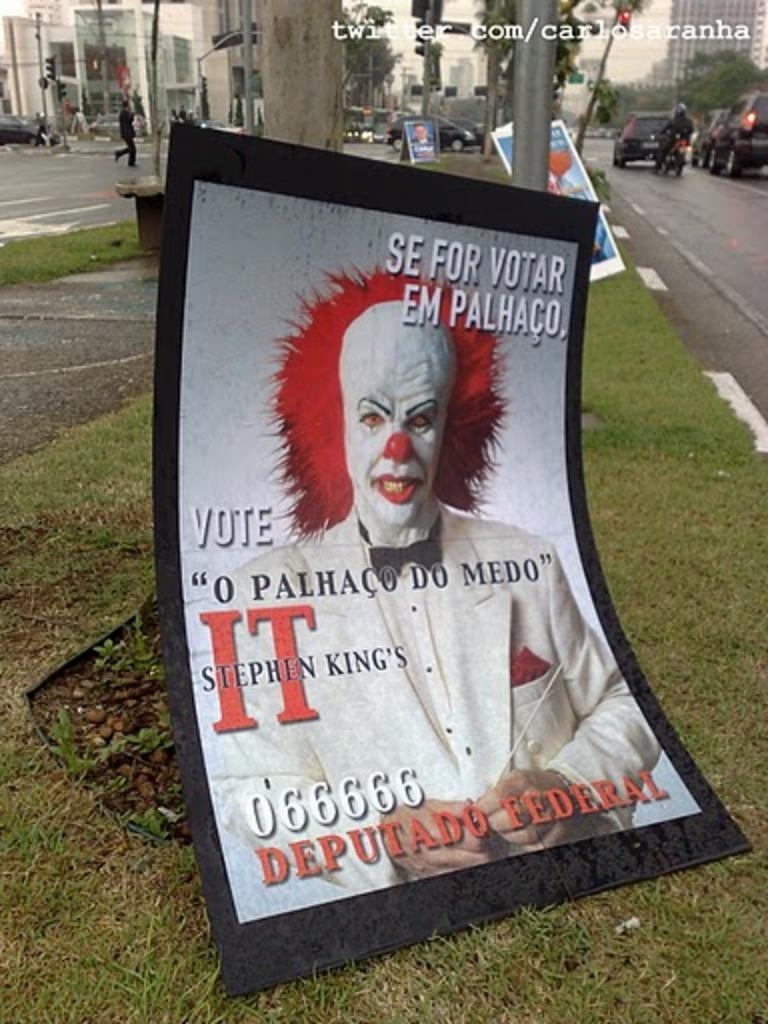<image>
Summarize the visual content of the image. A political campaign poster tells people to vote and has a picture of a clown on it. 